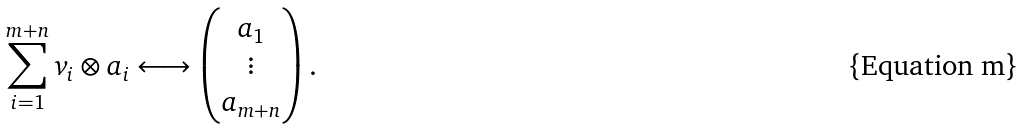Convert formula to latex. <formula><loc_0><loc_0><loc_500><loc_500>\sum _ { i = 1 } ^ { m + n } v _ { i } \otimes a _ { i } \longleftrightarrow \left ( \begin{matrix} a _ { 1 } \\ \vdots \\ a _ { m + n } \end{matrix} \right ) .</formula> 